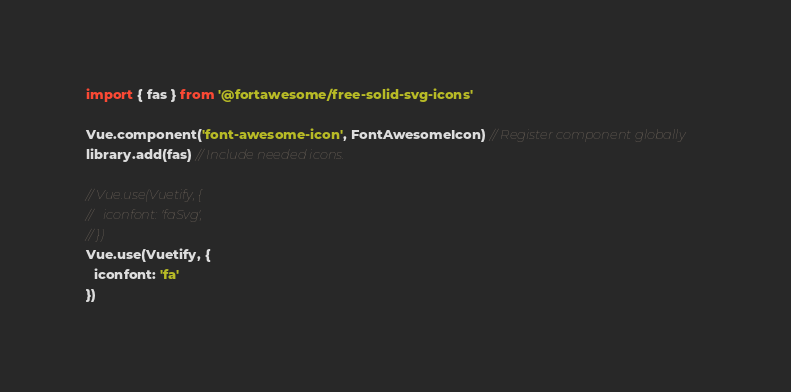<code> <loc_0><loc_0><loc_500><loc_500><_JavaScript_>import { fas } from '@fortawesome/free-solid-svg-icons'

Vue.component('font-awesome-icon', FontAwesomeIcon) // Register component globally
library.add(fas) // Include needed icons.

// Vue.use(Vuetify, {
//   iconfont: 'faSvg',
// })
Vue.use(Vuetify, {
  iconfont: 'fa'
})
</code> 